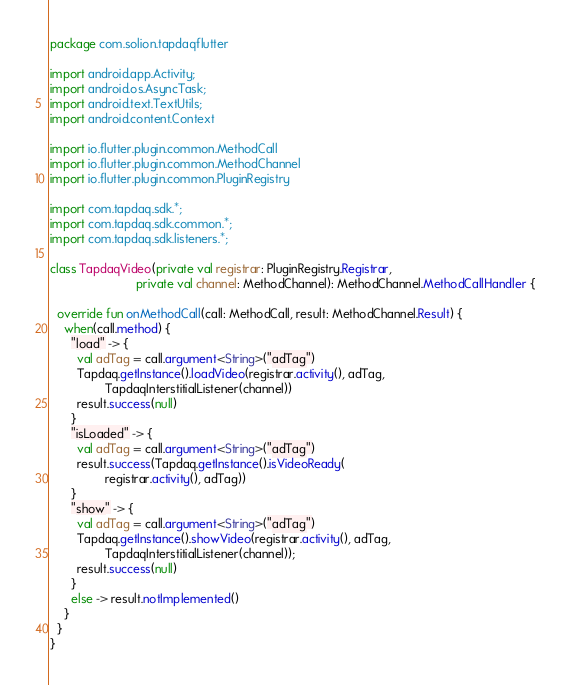Convert code to text. <code><loc_0><loc_0><loc_500><loc_500><_Kotlin_>package com.solion.tapdaqflutter

import android.app.Activity;
import android.os.AsyncTask;
import android.text.TextUtils;
import android.content.Context

import io.flutter.plugin.common.MethodCall
import io.flutter.plugin.common.MethodChannel
import io.flutter.plugin.common.PluginRegistry

import com.tapdaq.sdk.*;
import com.tapdaq.sdk.common.*;
import com.tapdaq.sdk.listeners.*;

class TapdaqVideo(private val registrar: PluginRegistry.Registrar,
                         private val channel: MethodChannel): MethodChannel.MethodCallHandler {

  override fun onMethodCall(call: MethodCall, result: MethodChannel.Result) {
    when(call.method) {
      "load" -> {
        val adTag = call.argument<String>("adTag")
        Tapdaq.getInstance().loadVideo(registrar.activity(), adTag,
                TapdaqInterstitialListener(channel))
        result.success(null)
      }
      "isLoaded" -> {
        val adTag = call.argument<String>("adTag")
        result.success(Tapdaq.getInstance().isVideoReady(
                registrar.activity(), adTag))
      }
      "show" -> {
        val adTag = call.argument<String>("adTag")
        Tapdaq.getInstance().showVideo(registrar.activity(), adTag,
                TapdaqInterstitialListener(channel));
        result.success(null)
      }
      else -> result.notImplemented()
    }
  }
}
</code> 